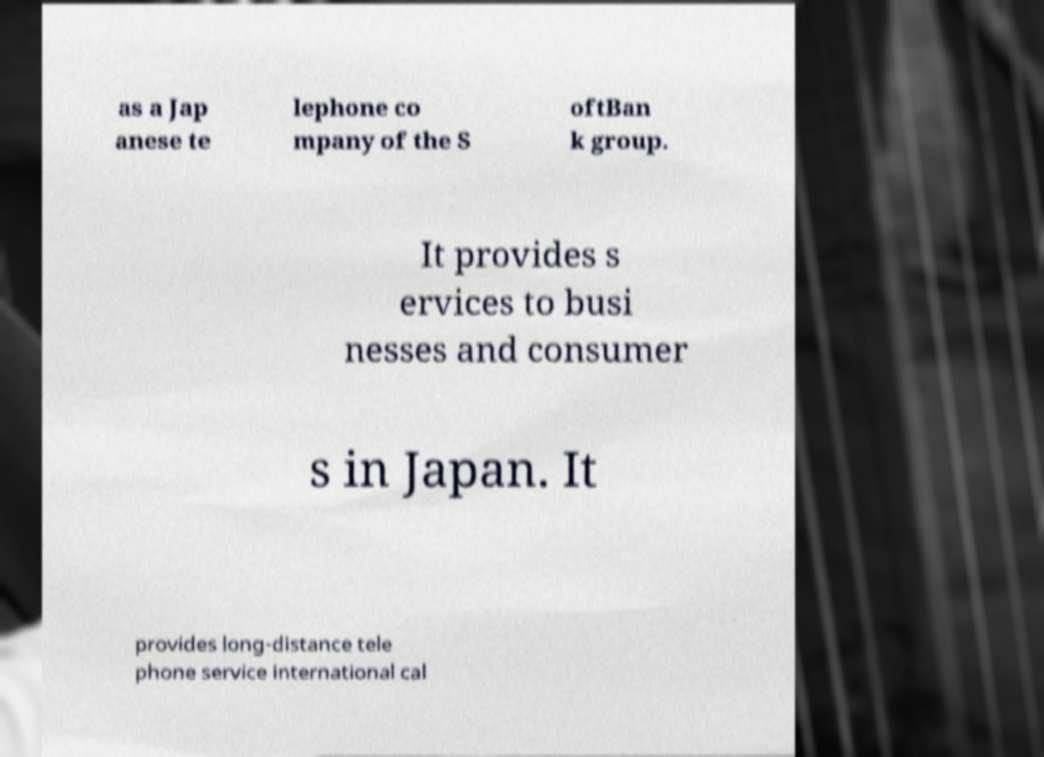Please identify and transcribe the text found in this image. as a Jap anese te lephone co mpany of the S oftBan k group. It provides s ervices to busi nesses and consumer s in Japan. It provides long-distance tele phone service international cal 